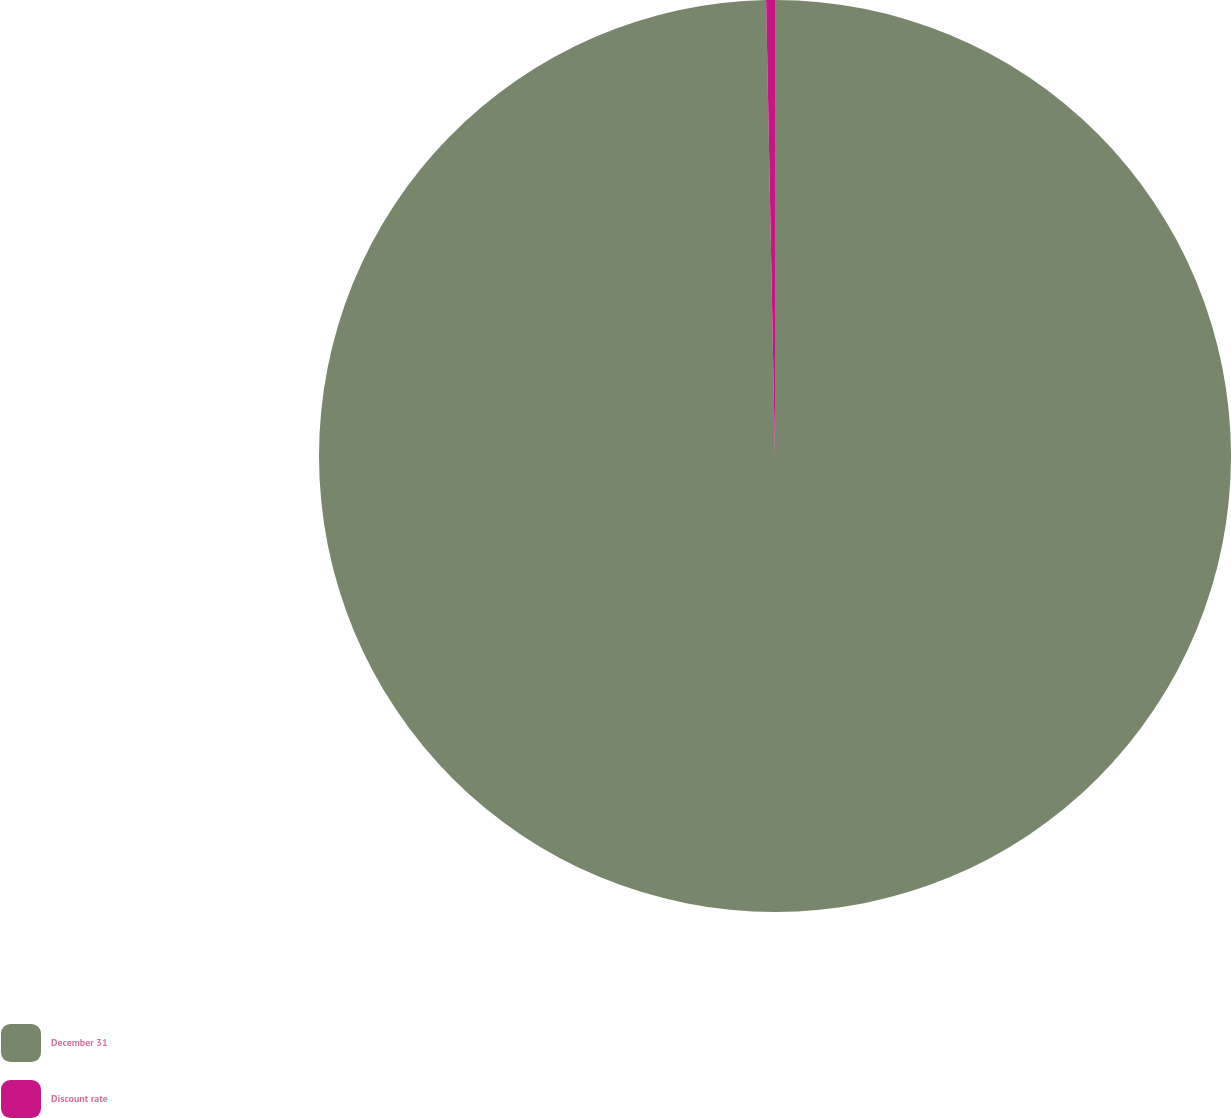<chart> <loc_0><loc_0><loc_500><loc_500><pie_chart><fcel>December 31<fcel>Discount rate<nl><fcel>99.69%<fcel>0.31%<nl></chart> 